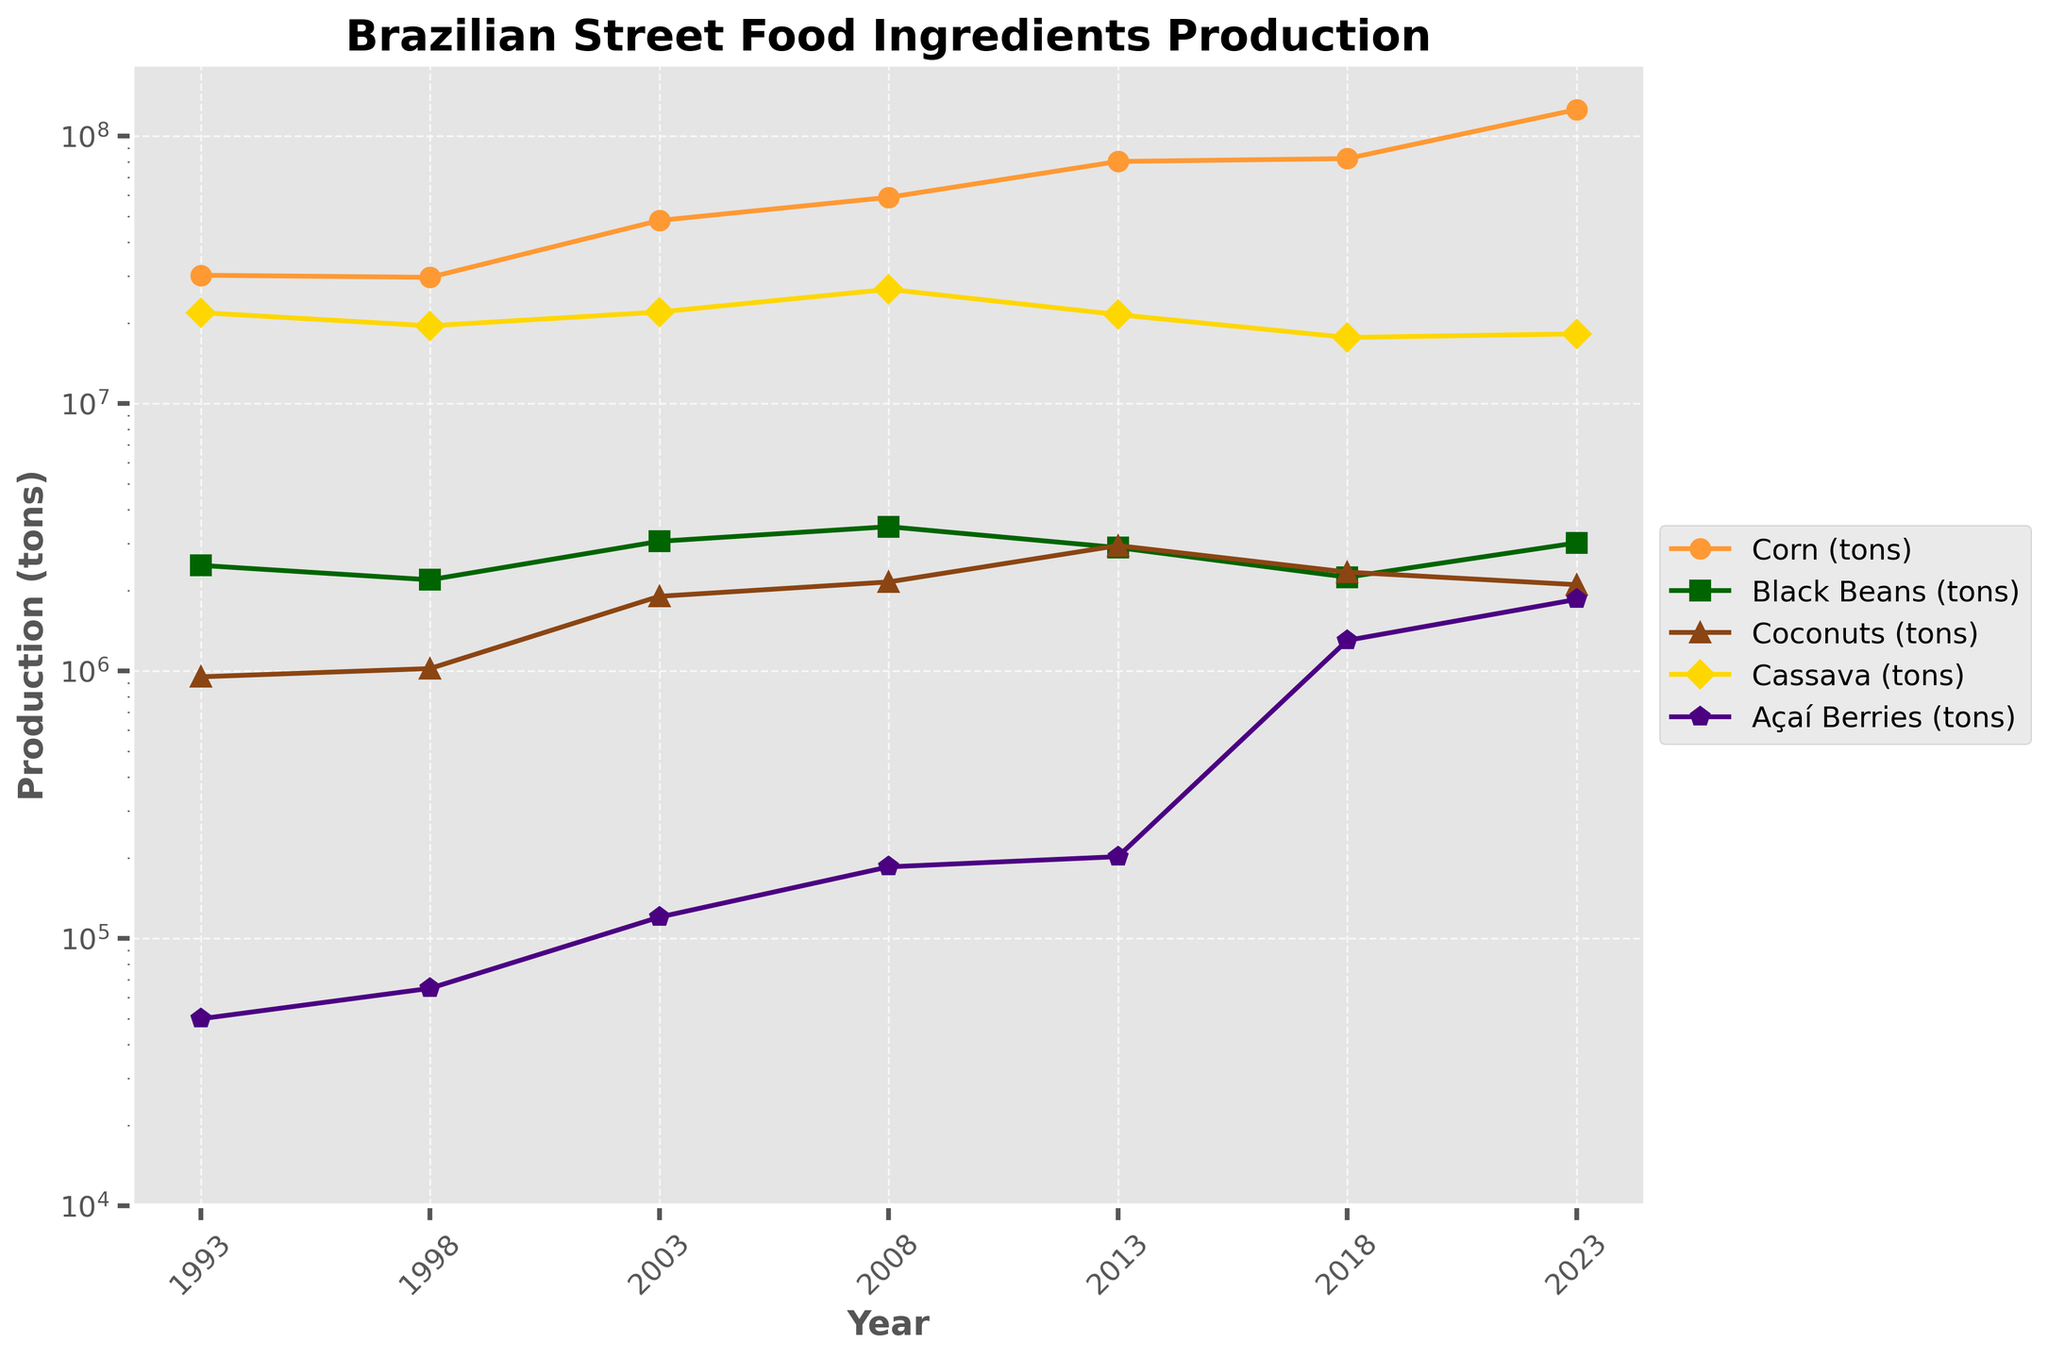Which ingredient shows the highest production increase from 1993 to 2023? To find the ingredient with the highest production increase, we need to subtract the 1993 production values from the 2023 values for each ingredient. Corn (tons): 125500000 - 30150000 = 95350000, Black Beans (tons): 3010000 - 2480000 = 530000, Coconuts (tons): 2100000 - 950000 = 1150000, Cassava (tons): 18200000 - 21850000 = -3650000, Açaí Berries (tons): 1850000 - 50000 = 1800000. Corn shows the highest increase.
Answer: Corn What is the average production of Black Beans from 1993 to 2023? To find the average production, sum the production values of Black Beans for all years and divide by the number of years. (2480000 + 2190000 + 3050000 + 3460000 + 2890000 + 2240000 + 3010000) / 7 = 2765714.2857 tons.
Answer: 2765714.2857 tons Which ingredient had a production peak in 2013 compared to other years? Compare the production values of each ingredient across all years. The ingredient with the highest value in 2013 and not surpassed by any other year is observed by inspecting each line's highest point. Açaí Berries peak at 202000 tons in 2013, higher than any other year for itself but not the highest relative peak compared to all ingredients. However, production values for all other ingredients are not as notable for 2013. Therefore, Açaí Berries had a notable peak in 2013.
Answer: Açaí Berries Between which years did Corn see its most significant rise in production? By analyzing the intervals between the years, we observe the highest differences in Corn production. From 2018 to 2023, the increase is 125500000 - 82280000 = 43220000 tons, which is the highest among all intervals.
Answer: 2018 to 2023 In which year was the production of Cassava the highest? Inspect the production values of Cassava across all years and identify the year with the highest value. The highest production value for Cassava is in 2008 with 26700000 tons.
Answer: 2008 What is the total production of Coconuts for all given years? Summing up the production values of Coconuts for all years: 950000 + 1020000 + 1900000 + 2150000 + 2940000 + 2340000 + 2100000 = 14000000 tons.
Answer: 14000000 tons Which ingredient consistently shows a steady increase in production over the years? By reviewing the lines and their trends, Corn shows a consistent upward trend across all years without significant drops, meaning it has steadily increased continuously.
Answer: Corn How much did the Açaí Berries production grow between 1998 and 2018? To find the growth, subtract the 1998 production value from the 2018 production value for Açaí Berries: 1300000 - 65000 = 1235000 tons.
Answer: 1235000 tons Which year did Black Beans production decrease the most compared to the previous year? By examining each pair of successive years, the most significant decrease is from 2008 (3460000 tons) to 2013 (2890000 tons). The decrease is 3460000 - 2890000 = 570000 tons, which is the largest drop.
Answer: 2013 